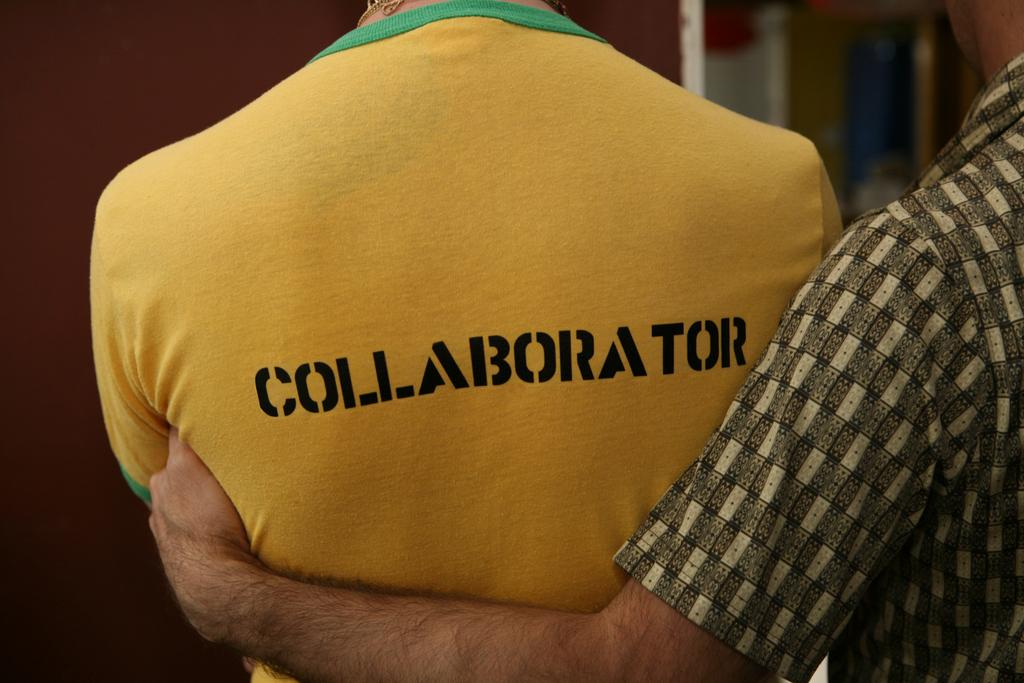What is on the right side of the image? There is a person in a shirt on the right side of the image. What is the person in the shirt doing? The person in the shirt is holding another person. What is the person being held wearing? The person being held is wearing a yellow t-shirt. What can be seen on the yellow t-shirt? The yellow t-shirt has black text on it. How would you describe the background of the image? The background of the image is blurred. What color is the bag that the sun is holding in the image? There is no bag or sun present in the image. 